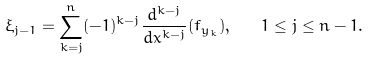<formula> <loc_0><loc_0><loc_500><loc_500>\xi _ { j - 1 } = \sum _ { k = j } ^ { n } ( - 1 ) ^ { k - j } \frac { d ^ { k - j } } { d x ^ { k - j } } ( f _ { y _ { k } } ) , \quad 1 \leq j \leq n - 1 .</formula> 